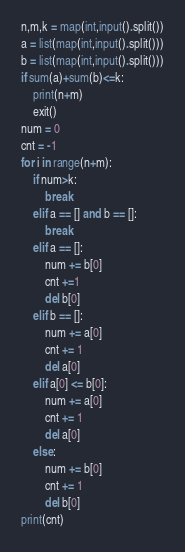Convert code to text. <code><loc_0><loc_0><loc_500><loc_500><_Python_>n,m,k = map(int,input().split())
a = list(map(int,input().split()))
b = list(map(int,input().split()))
if sum(a)+sum(b)<=k:
    print(n+m)
    exit()
num = 0
cnt = -1
for i in range(n+m):
    if num>k:
        break
    elif a == [] and b == []:
        break
    elif a == []:
        num += b[0]
        cnt +=1
        del b[0]
    elif b == []:
        num += a[0]
        cnt += 1
        del a[0]
    elif a[0] <= b[0]:
        num += a[0]
        cnt += 1
        del a[0]
    else:
        num += b[0]
        cnt += 1
        del b[0]
print(cnt)</code> 